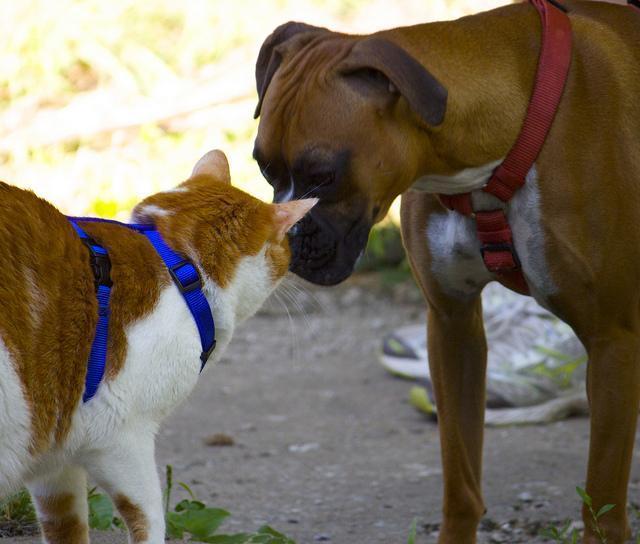How many shoes do you see?
Give a very brief answer. 2. How many people are wearing orange shirts?
Give a very brief answer. 0. 